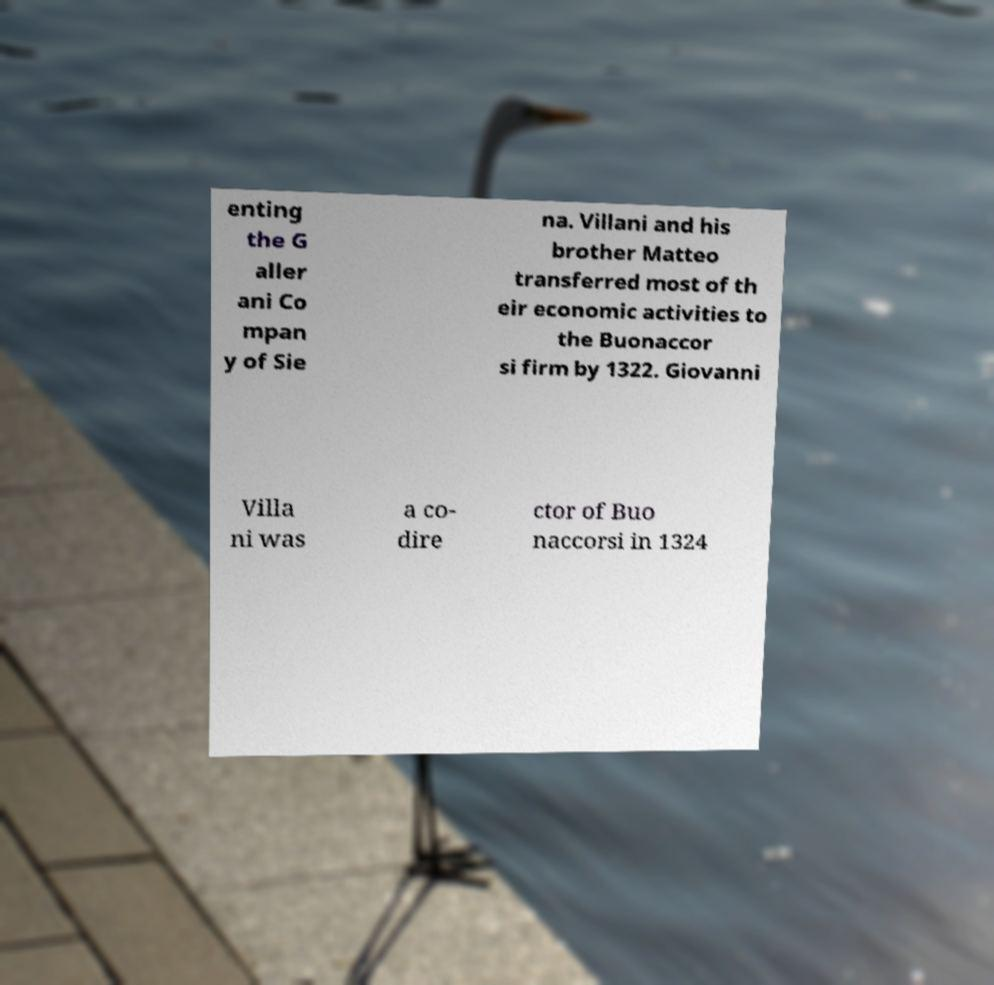There's text embedded in this image that I need extracted. Can you transcribe it verbatim? enting the G aller ani Co mpan y of Sie na. Villani and his brother Matteo transferred most of th eir economic activities to the Buonaccor si firm by 1322. Giovanni Villa ni was a co- dire ctor of Buo naccorsi in 1324 